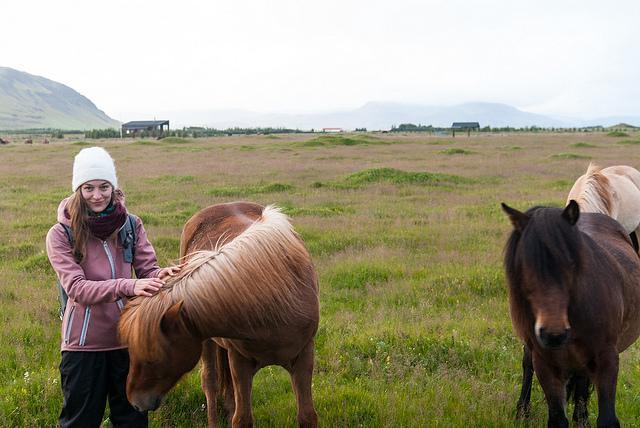How many horses are there?
Give a very brief answer. 3. How many horses can be seen?
Give a very brief answer. 3. How many glass bottles are on the table?
Give a very brief answer. 0. 